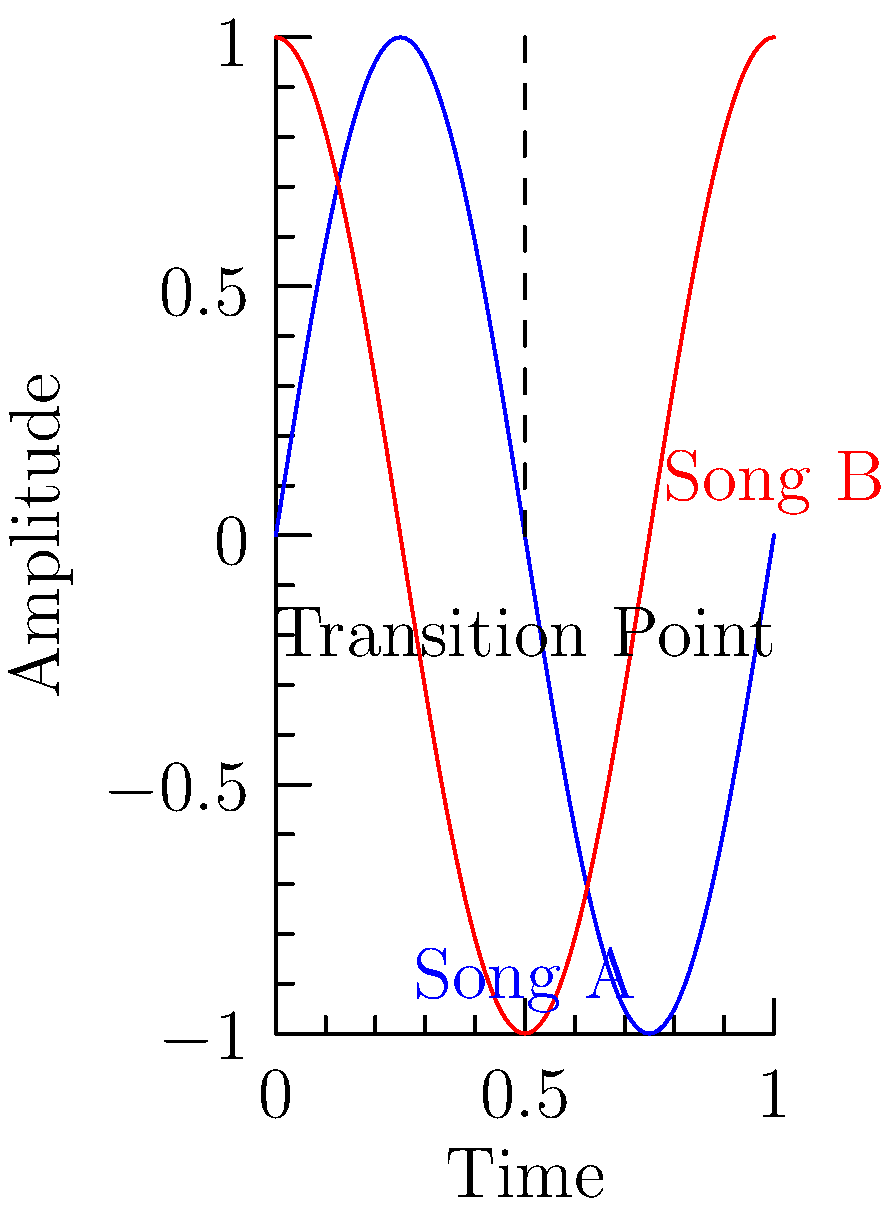In the graph above, two waveforms representing the beats of different songs are shown. Song A (blue) and Song B (red) intersect at the transition point. What vector operation would best describe the process of smoothly transitioning from Song A to Song B at this point to maintain consistent energy in the mix? To smoothly transition between two songs while maintaining consistent energy, we need to consider the following steps:

1. Identify the transition point: This is where the two waveforms intersect, indicating a moment where both songs have similar amplitude and phase.

2. Analyze the vectors: Each waveform can be thought of as a vector in time, with magnitude representing amplitude and direction representing phase.

3. Vector addition: To create a smooth transition, we want to gradually blend the two vectors. This can be achieved through vector addition with varying weights.

4. Weighted average: As we approach the transition point, we gradually decrease the weight of Song A's vector while increasing the weight of Song B's vector. This can be represented mathematically as:

   $$\vec{R} = (1-t)\vec{A} + t\vec{B}$$

   Where $\vec{R}$ is the resulting vector, $\vec{A}$ is Song A's vector, $\vec{B}$ is Song B's vector, and $t$ is a parameter that goes from 0 to 1 during the transition.

5. Smooth interpolation: To ensure a gradual transition, $t$ should change smoothly. This can be achieved using a function like the smoothstep function:

   $$t = 3x^2 - 2x^3$$

   Where $x$ goes from 0 to 1 during the transition period.

By applying this vector operation, we create a smooth crossfade between the two songs, maintaining consistent energy and avoiding abrupt changes in the mix.
Answer: Weighted vector addition 